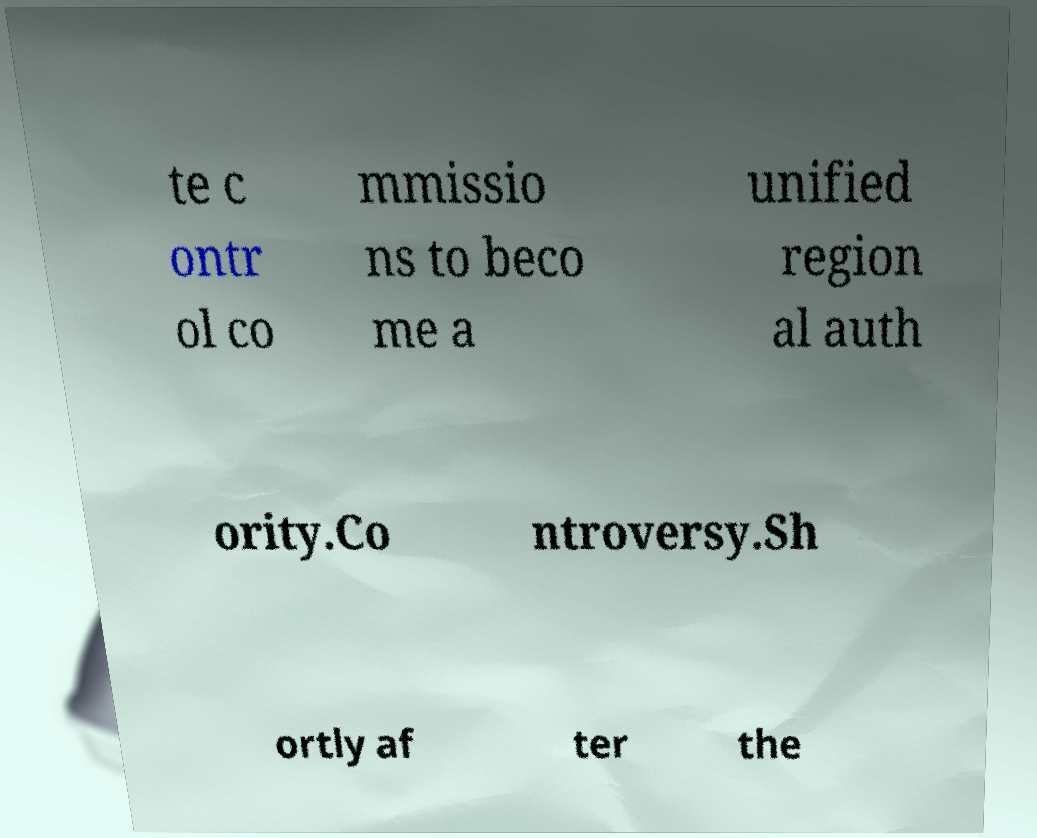Could you assist in decoding the text presented in this image and type it out clearly? te c ontr ol co mmissio ns to beco me a unified region al auth ority.Co ntroversy.Sh ortly af ter the 